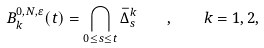Convert formula to latex. <formula><loc_0><loc_0><loc_500><loc_500>B _ { k } ^ { 0 , N , \varepsilon } ( t ) = \bigcap _ { 0 \leq s \leq t } \bar { \Delta } _ { s } ^ { k } \quad , \quad k = 1 , 2 ,</formula> 